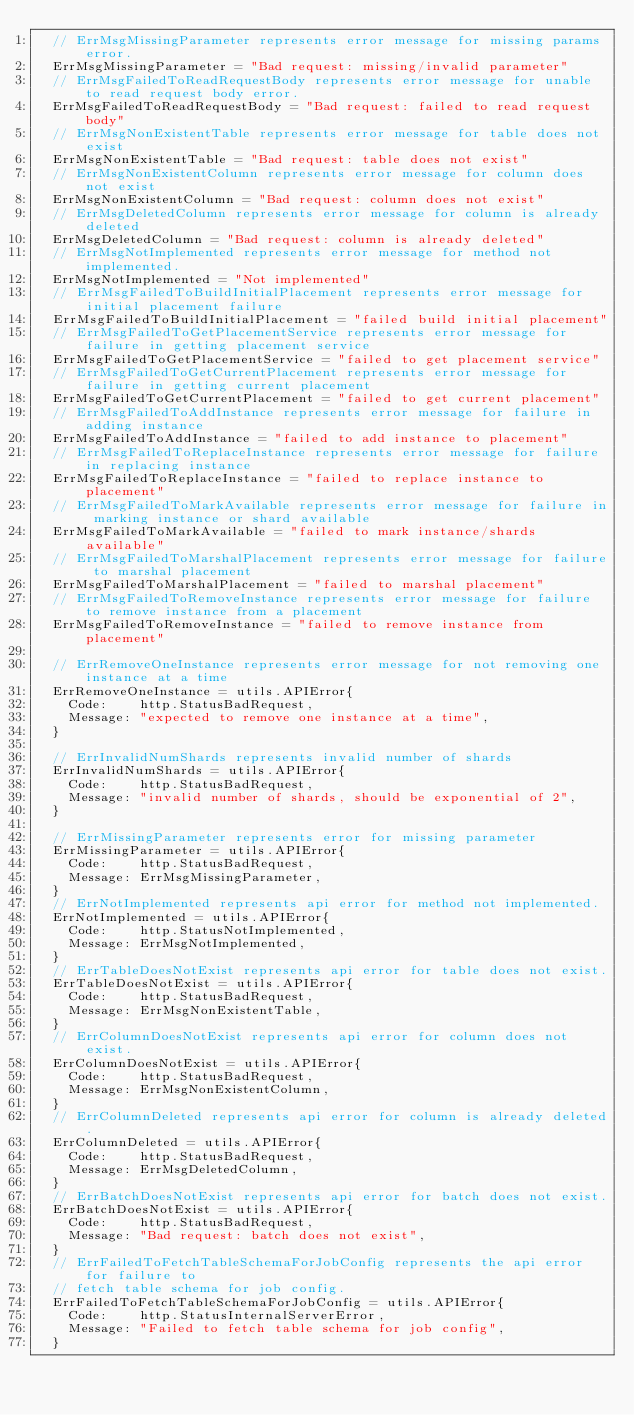Convert code to text. <code><loc_0><loc_0><loc_500><loc_500><_Go_>	// ErrMsgMissingParameter represents error message for missing params error.
	ErrMsgMissingParameter = "Bad request: missing/invalid parameter"
	// ErrMsgFailedToReadRequestBody represents error message for unable to read request body error.
	ErrMsgFailedToReadRequestBody = "Bad request: failed to read request body"
	// ErrMsgNonExistentTable represents error message for table does not exist
	ErrMsgNonExistentTable = "Bad request: table does not exist"
	// ErrMsgNonExistentColumn represents error message for column does not exist
	ErrMsgNonExistentColumn = "Bad request: column does not exist"
	// ErrMsgDeletedColumn represents error message for column is already deleted
	ErrMsgDeletedColumn = "Bad request: column is already deleted"
	// ErrMsgNotImplemented represents error message for method not implemented.
	ErrMsgNotImplemented = "Not implemented"
	// ErrMsgFailedToBuildInitialPlacement represents error message for initial placement failure
	ErrMsgFailedToBuildInitialPlacement = "failed build initial placement"
	// ErrMsgFailedToGetPlacementService represents error message for failure in getting placement service
	ErrMsgFailedToGetPlacementService = "failed to get placement service"
	// ErrMsgFailedToGetCurrentPlacement represents error message for failure in getting current placement
	ErrMsgFailedToGetCurrentPlacement = "failed to get current placement"
	// ErrMsgFailedToAddInstance represents error message for failure in adding instance
	ErrMsgFailedToAddInstance = "failed to add instance to placement"
	// ErrMsgFailedToReplaceInstance represents error message for failure in replacing instance
	ErrMsgFailedToReplaceInstance = "failed to replace instance to placement"
	// ErrMsgFailedToMarkAvailable represents error message for failure in marking instance or shard available
	ErrMsgFailedToMarkAvailable = "failed to mark instance/shards available"
	// ErrMsgFailedToMarshalPlacement represents error message for failure to marshal placement
	ErrMsgFailedToMarshalPlacement = "failed to marshal placement"
	// ErrMsgFailedToRemoveInstance represents error message for failure to remove instance from a placement
	ErrMsgFailedToRemoveInstance = "failed to remove instance from placement"

	// ErrRemoveOneInstance represents error message for not removing one instance at a time
	ErrRemoveOneInstance = utils.APIError{
		Code:    http.StatusBadRequest,
		Message: "expected to remove one instance at a time",
	}

	// ErrInvalidNumShards represents invalid number of shards
	ErrInvalidNumShards = utils.APIError{
		Code:    http.StatusBadRequest,
		Message: "invalid number of shards, should be exponential of 2",
	}

	// ErrMissingParameter represents error for missing parameter
	ErrMissingParameter = utils.APIError{
		Code:    http.StatusBadRequest,
		Message: ErrMsgMissingParameter,
	}
	// ErrNotImplemented represents api error for method not implemented.
	ErrNotImplemented = utils.APIError{
		Code:    http.StatusNotImplemented,
		Message: ErrMsgNotImplemented,
	}
	// ErrTableDoesNotExist represents api error for table does not exist.
	ErrTableDoesNotExist = utils.APIError{
		Code:    http.StatusBadRequest,
		Message: ErrMsgNonExistentTable,
	}
	// ErrColumnDoesNotExist represents api error for column does not exist.
	ErrColumnDoesNotExist = utils.APIError{
		Code:    http.StatusBadRequest,
		Message: ErrMsgNonExistentColumn,
	}
	// ErrColumnDeleted represents api error for column is already deleted.
	ErrColumnDeleted = utils.APIError{
		Code:    http.StatusBadRequest,
		Message: ErrMsgDeletedColumn,
	}
	// ErrBatchDoesNotExist represents api error for batch does not exist.
	ErrBatchDoesNotExist = utils.APIError{
		Code:    http.StatusBadRequest,
		Message: "Bad request: batch does not exist",
	}
	// ErrFailedToFetchTableSchemaForJobConfig represents the api error for failure to
	// fetch table schema for job config.
	ErrFailedToFetchTableSchemaForJobConfig = utils.APIError{
		Code:    http.StatusInternalServerError,
		Message: "Failed to fetch table schema for job config",
	}</code> 